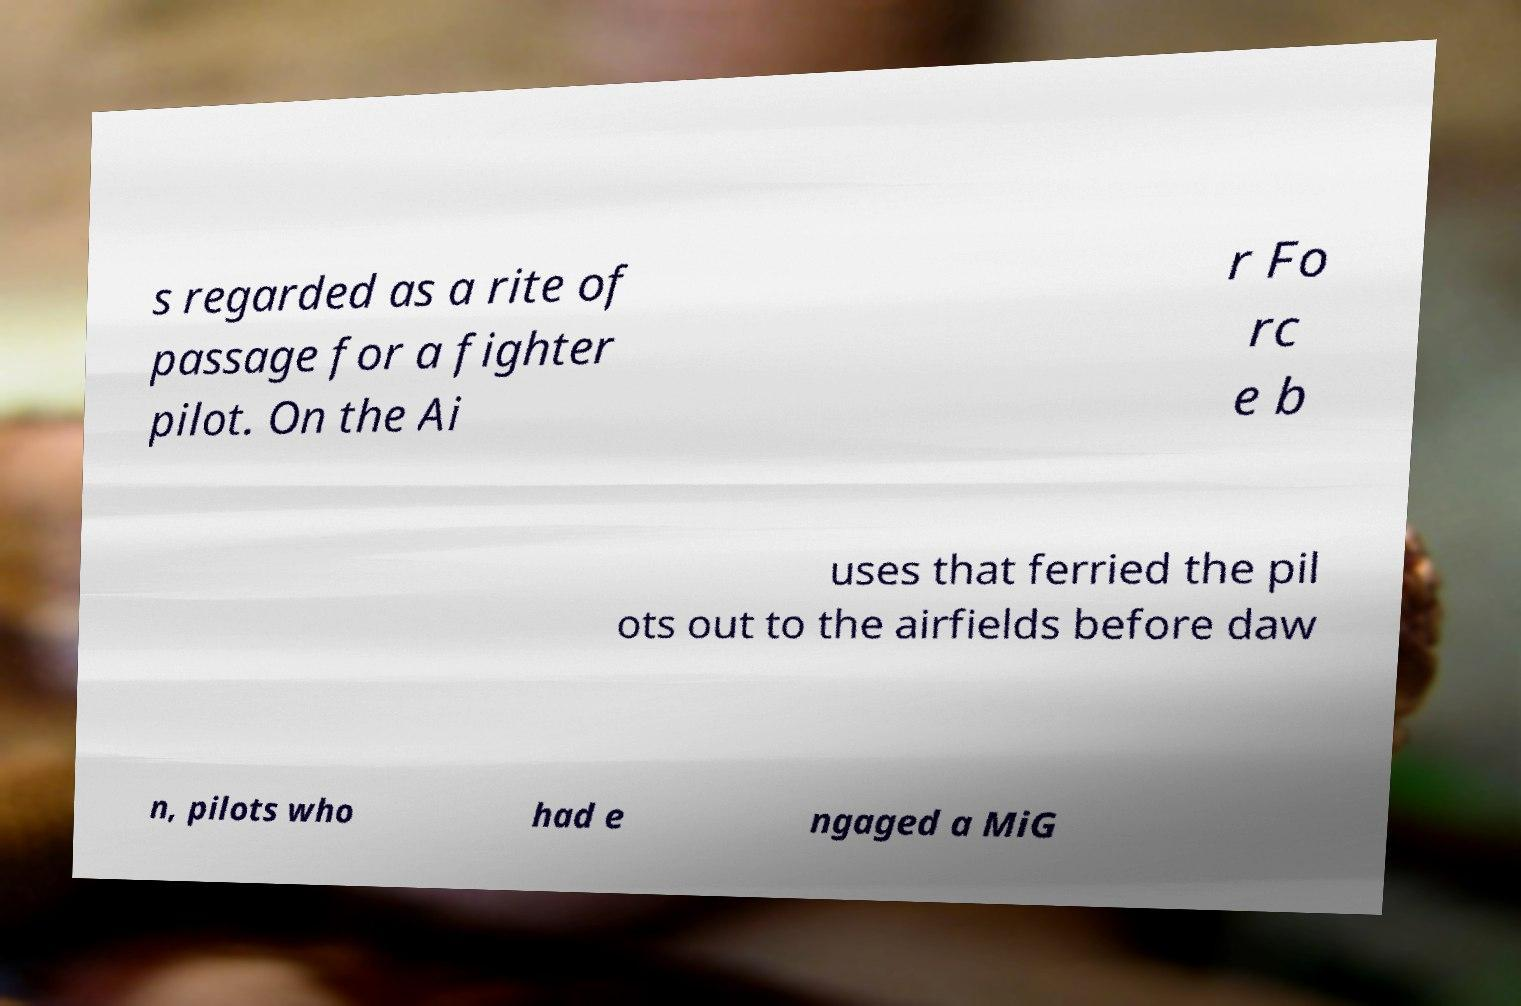Please read and relay the text visible in this image. What does it say? s regarded as a rite of passage for a fighter pilot. On the Ai r Fo rc e b uses that ferried the pil ots out to the airfields before daw n, pilots who had e ngaged a MiG 